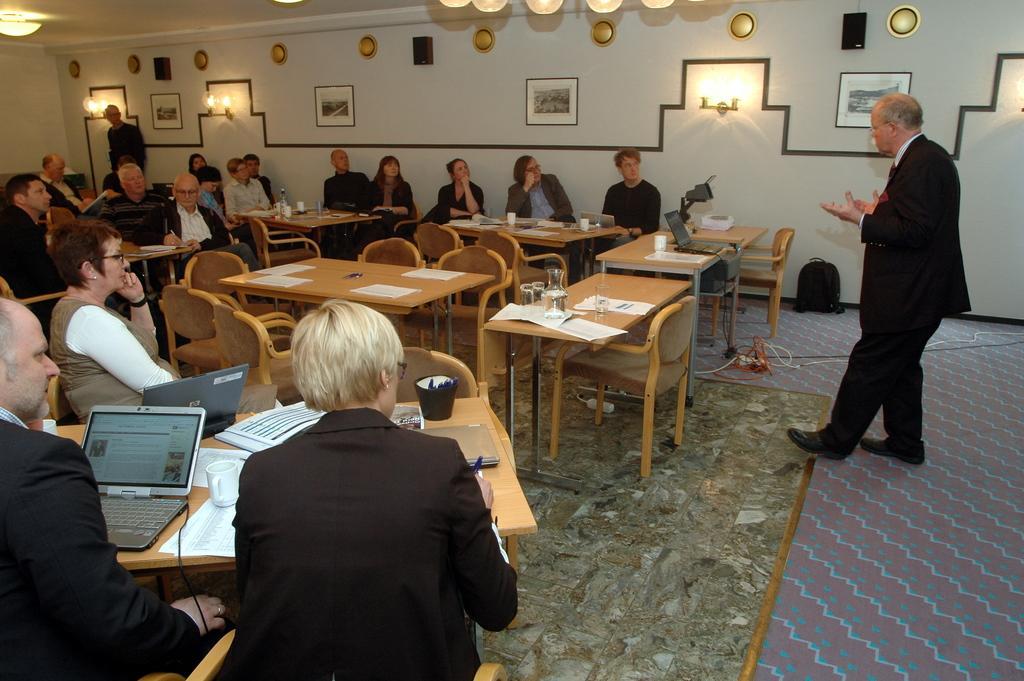Can you describe this image briefly? The image is taken in the room. On the right side there is a man standing and talking before him there are many tables and people sitting around the tables. There are glasses, papers, laptops, jars, mugs which are placed on the tables and there are photo frames which are attached to the walls. 